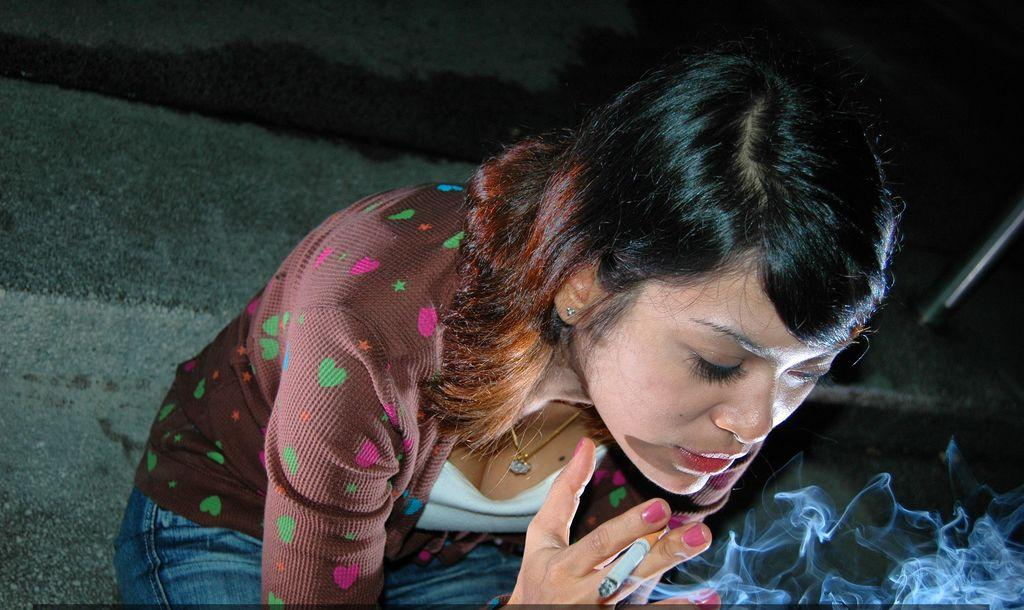Who is present in the image? There is a woman in the image. What is the woman holding in her hand? The woman is holding a cigarette in her hand. What can be seen as a result of the cigarette being smoked? Smoke is visible at the bottom of the image. How many goldfish are swimming in the image? There are no goldfish present in the image. What instruction is given to the woman in the image to stop smoking? The image does not provide any instructions or dialogue, so it cannot be determined if the woman is being told to stop smoking. 